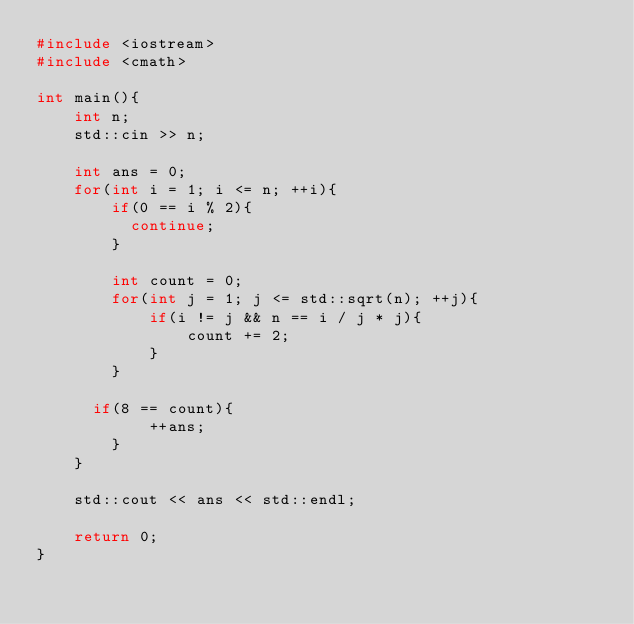<code> <loc_0><loc_0><loc_500><loc_500><_C++_>#include <iostream>
#include <cmath>

int main(){
    int n;
    std::cin >> n;
  
  	int ans = 0;
  	for(int i = 1; i <= n; ++i){
		if(0 == i % 2){
          continue;
        }
      
      	int count = 0;
		for(int j = 1; j <= std::sqrt(n); ++j){
          	if(i != j && n == i / j * j){
               	count += 2;
            }
        }

      if(8 == count){
          	++ans;
        }
    }
  
  	std::cout << ans << std::endl;
  
    return 0;
}</code> 